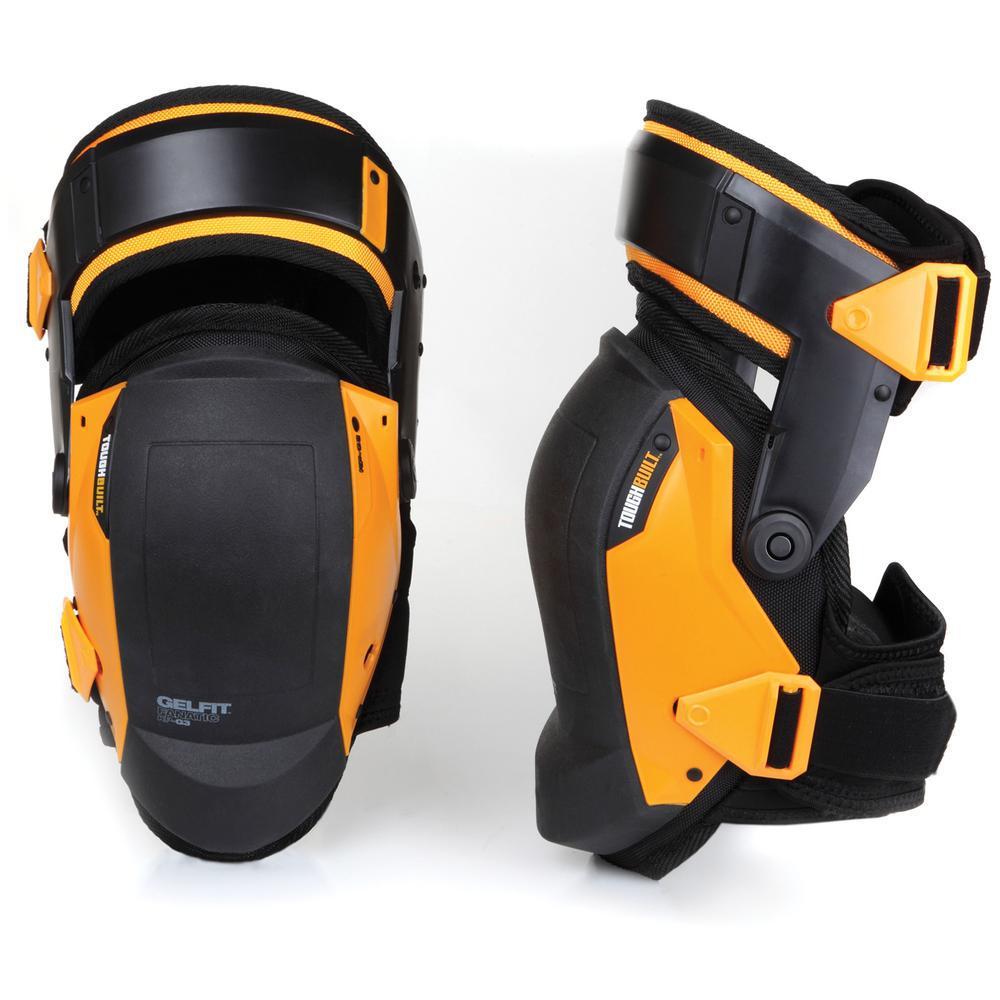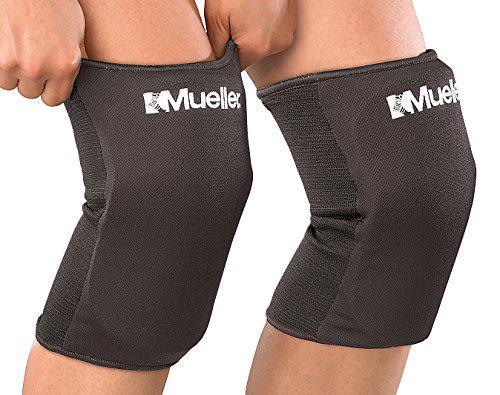The first image is the image on the left, the second image is the image on the right. Examine the images to the left and right. Is the description "An image shows a black knee pad modeled on a human leg." accurate? Answer yes or no. Yes. The first image is the image on the left, the second image is the image on the right. Given the left and right images, does the statement "A person is modeling the knee pads in one of the images." hold true? Answer yes or no. Yes. 